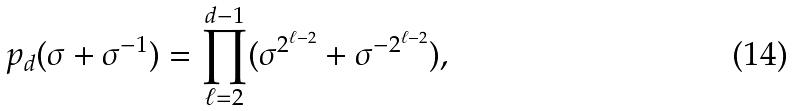<formula> <loc_0><loc_0><loc_500><loc_500>p _ { d } ( \sigma + \sigma ^ { - 1 } ) = \prod _ { \ell = 2 } ^ { d - 1 } ( \sigma ^ { 2 ^ { \ell - 2 } } + \sigma ^ { - 2 ^ { \ell - 2 } } ) ,</formula> 